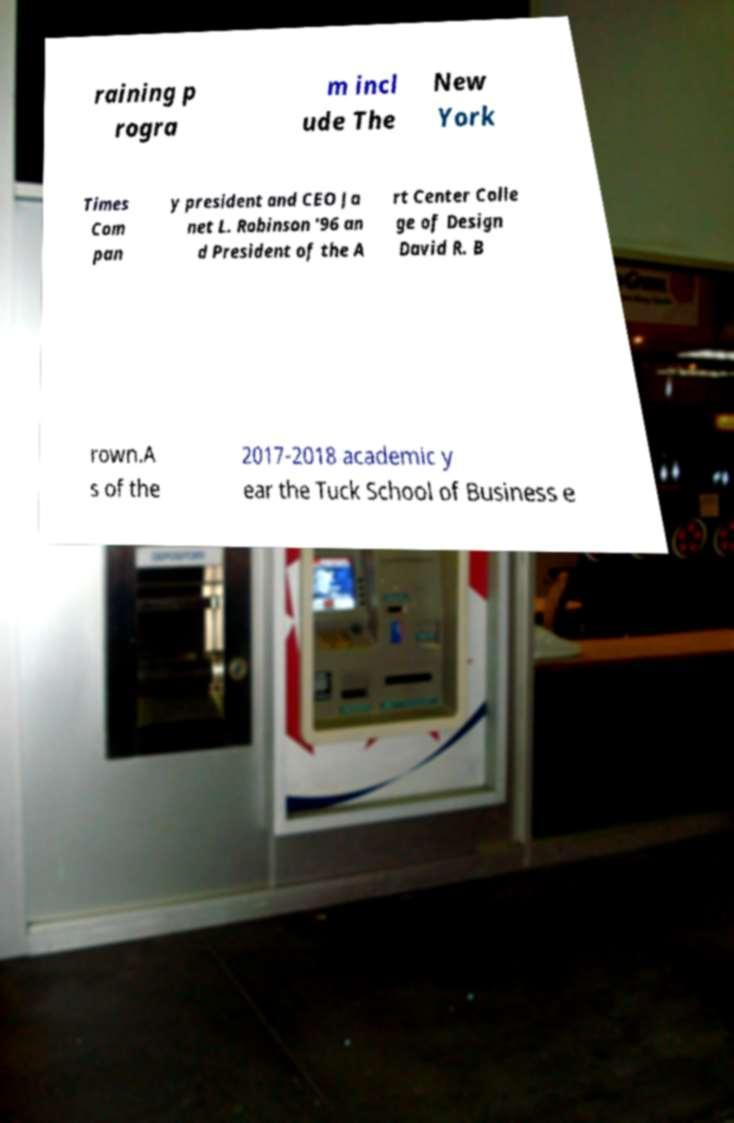Please read and relay the text visible in this image. What does it say? raining p rogra m incl ude The New York Times Com pan y president and CEO Ja net L. Robinson '96 an d President of the A rt Center Colle ge of Design David R. B rown.A s of the 2017-2018 academic y ear the Tuck School of Business e 